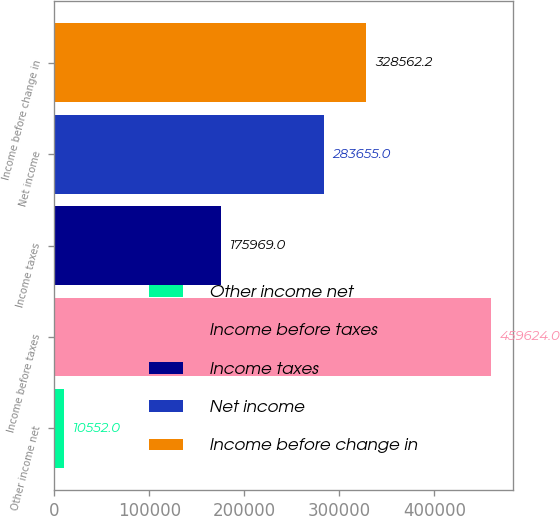Convert chart to OTSL. <chart><loc_0><loc_0><loc_500><loc_500><bar_chart><fcel>Other income net<fcel>Income before taxes<fcel>Income taxes<fcel>Net income<fcel>Income before change in<nl><fcel>10552<fcel>459624<fcel>175969<fcel>283655<fcel>328562<nl></chart> 